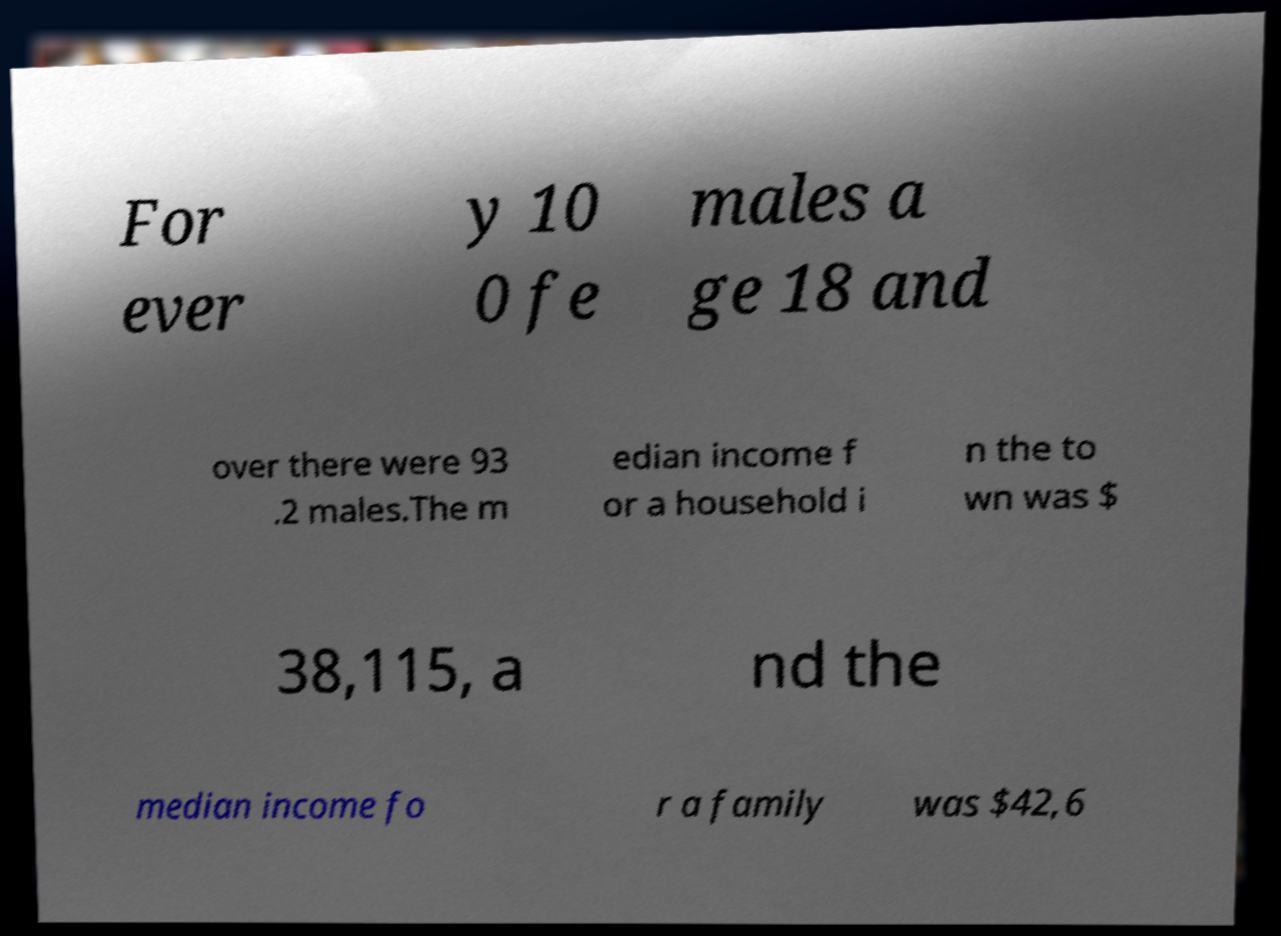I need the written content from this picture converted into text. Can you do that? For ever y 10 0 fe males a ge 18 and over there were 93 .2 males.The m edian income f or a household i n the to wn was $ 38,115, a nd the median income fo r a family was $42,6 